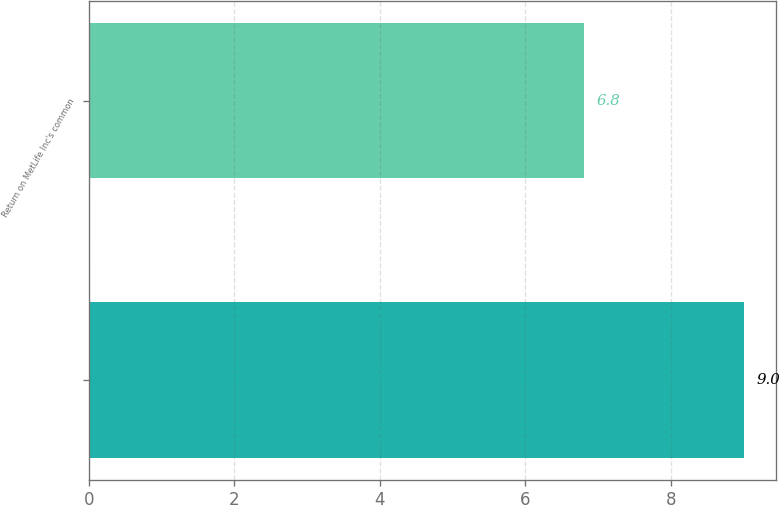<chart> <loc_0><loc_0><loc_500><loc_500><bar_chart><ecel><fcel>Return on MetLife Inc's common<nl><fcel>9<fcel>6.8<nl></chart> 